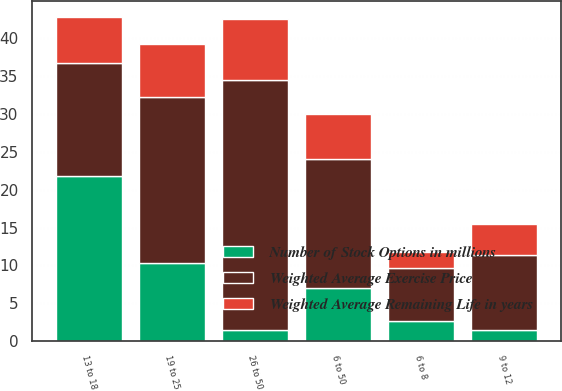Convert chart. <chart><loc_0><loc_0><loc_500><loc_500><stacked_bar_chart><ecel><fcel>6 to 8<fcel>9 to 12<fcel>13 to 18<fcel>19 to 25<fcel>26 to 50<fcel>6 to 50<nl><fcel>Number of Stock Options in millions<fcel>2.7<fcel>1.4<fcel>21.8<fcel>10.3<fcel>1.5<fcel>7<nl><fcel>Weighted Average Remaining Life in years<fcel>2<fcel>4<fcel>6<fcel>7<fcel>8<fcel>6<nl><fcel>Weighted Average Exercise Price<fcel>7<fcel>10<fcel>15<fcel>22<fcel>33<fcel>17<nl></chart> 